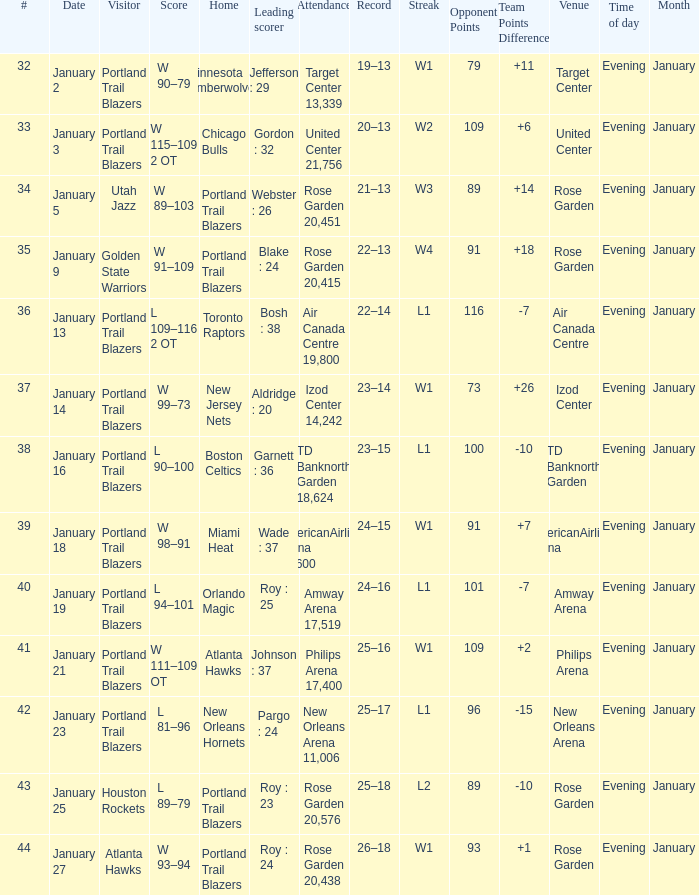What is the total number of dates where the scorer is gordon : 32 1.0. 